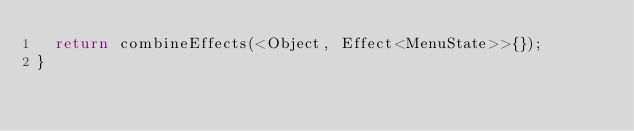<code> <loc_0><loc_0><loc_500><loc_500><_Dart_>  return combineEffects(<Object, Effect<MenuState>>{});
}
</code> 